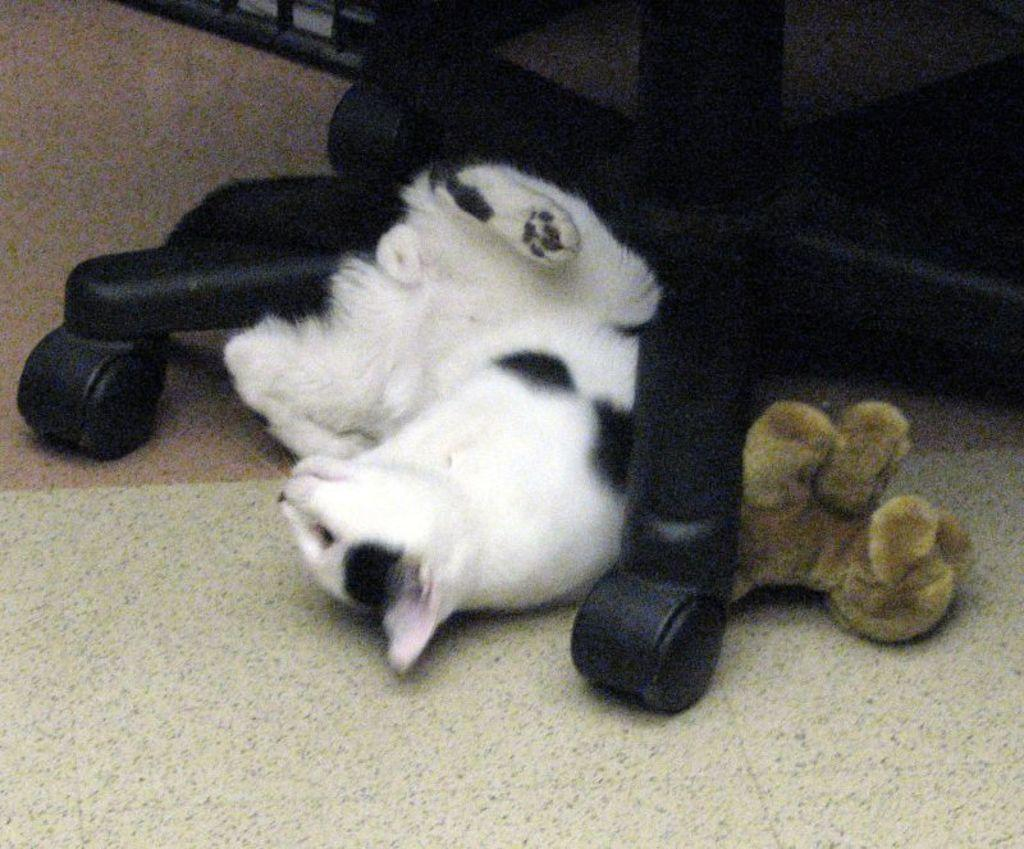What type of furniture is present in the image? There is a chair in the image. What type of animal is present in the image? There is a cat in the image. What type of object is present in the image? There is a toy in the image. Where are all of these objects located in the image? All of these objects are on the floor. What type of pen is being used by the ghost in the image? There is no ghost present in the image, so there is no pen being used by a ghost. 